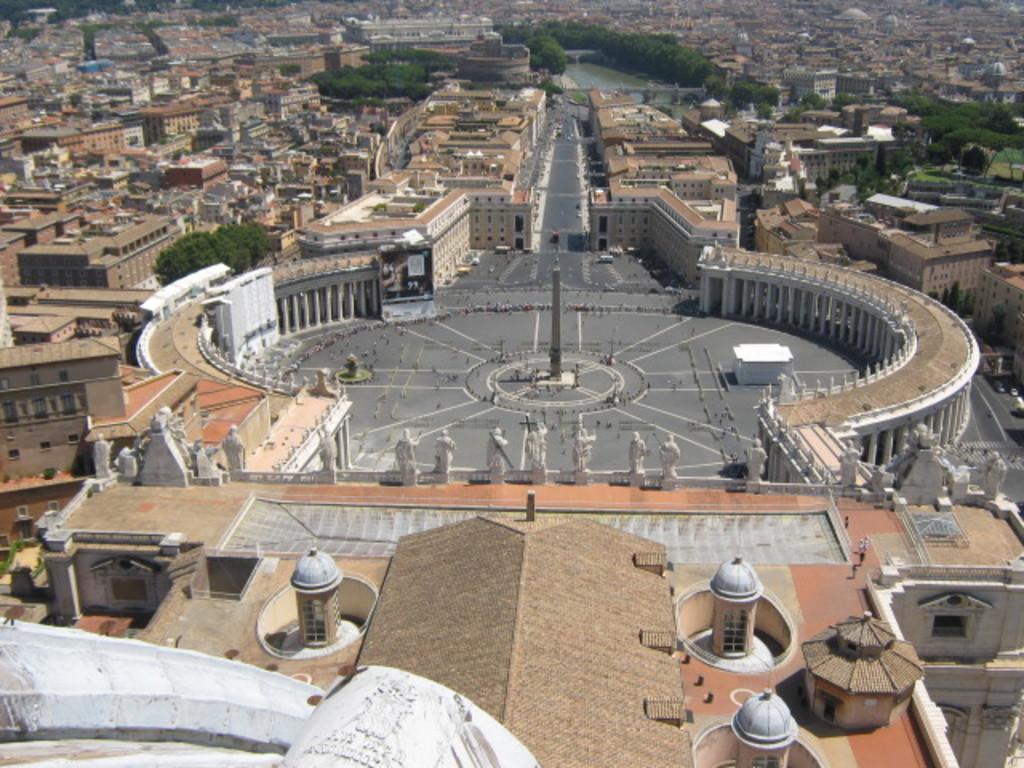Describe this image in one or two sentences. In this image we can see a group of buildings. On the backside we can see the water and some trees. 